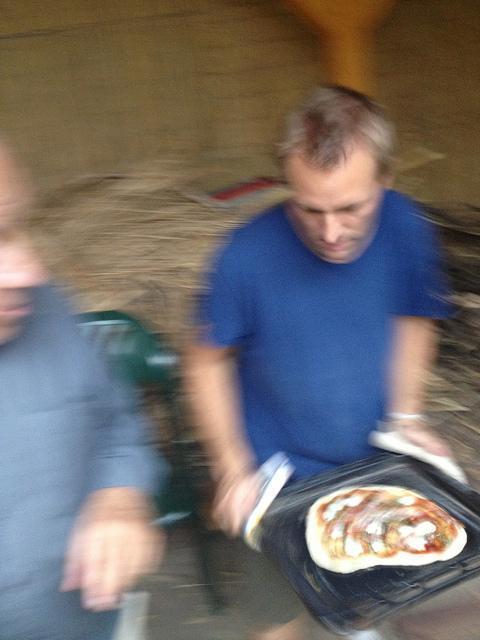How many people are in the picture?
Give a very brief answer. 2. How many people are there?
Give a very brief answer. 2. 